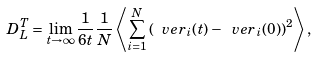<formula> <loc_0><loc_0><loc_500><loc_500>D _ { L } ^ { T } = \lim _ { t \rightarrow \infty } \frac { 1 } { 6 t } \frac { 1 } { N } \left \langle \sum _ { i = 1 } ^ { N } \left ( \ v e r _ { i } ( t ) - \ v e r _ { i } ( 0 ) \right ) ^ { 2 } \right \rangle ,</formula> 